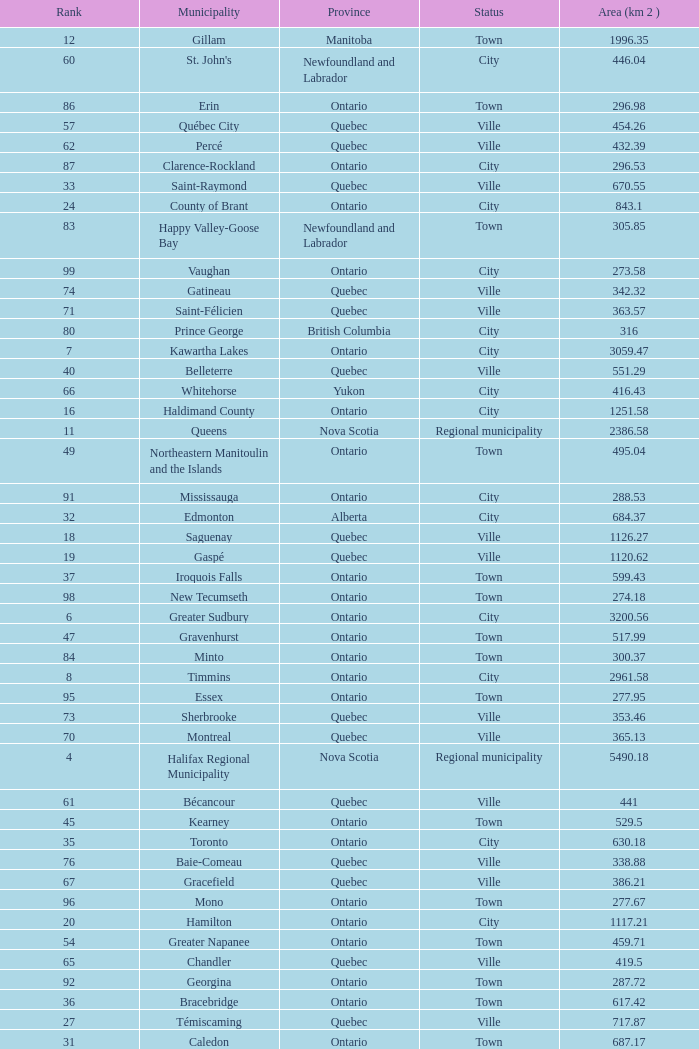What's the total of Rank that has an Area (KM 2) of 1050.14? 22.0. 